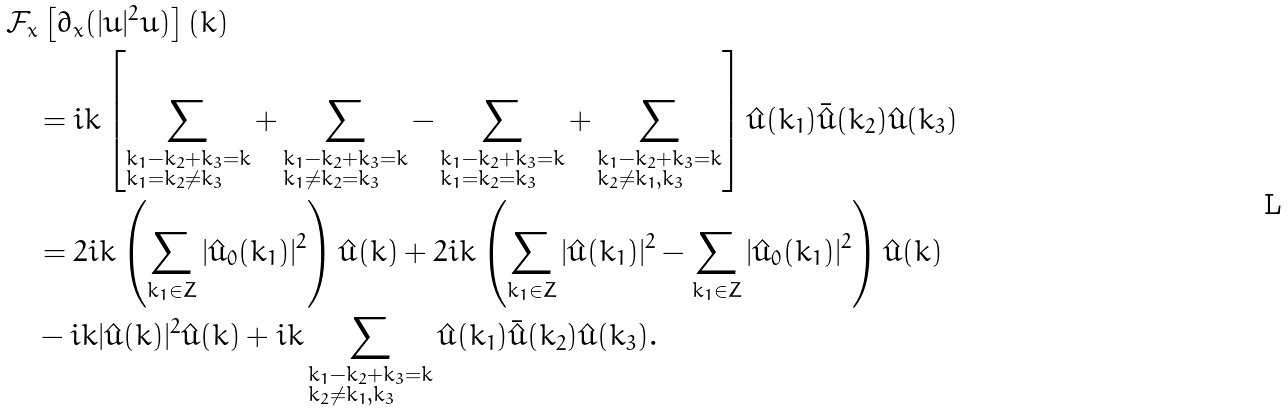Convert formula to latex. <formula><loc_0><loc_0><loc_500><loc_500>& \mathcal { F } _ { x } \left [ \partial _ { x } ( | u | ^ { 2 } u ) \right ] ( k ) \\ & \quad = i k \left [ \sum _ { \begin{subarray} { c } k _ { 1 } - k _ { 2 } + k _ { 3 } = k \\ k _ { 1 } = k _ { 2 } \neq k _ { 3 } \end{subarray} } + \sum _ { \begin{subarray} { c } k _ { 1 } - k _ { 2 } + k _ { 3 } = k \\ k _ { 1 } \neq k _ { 2 } = k _ { 3 } \end{subarray} } - \sum _ { \begin{subarray} { c } k _ { 1 } - k _ { 2 } + k _ { 3 } = k \\ k _ { 1 } = k _ { 2 } = k _ { 3 } \end{subarray} } + \sum _ { \begin{subarray} { c } k _ { 1 } - k _ { 2 } + k _ { 3 } = k \\ k _ { 2 } \neq k _ { 1 } , k _ { 3 } \end{subarray} } \right ] \hat { u } ( k _ { 1 } ) \bar { \hat { u } } ( k _ { 2 } ) \hat { u } ( k _ { 3 } ) \\ & \quad = 2 i k \left ( \sum _ { k _ { 1 } \in Z } | \hat { u } _ { 0 } ( k _ { 1 } ) | ^ { 2 } \right ) \hat { u } ( k ) + 2 i k \left ( \sum _ { k _ { 1 } \in Z } | \hat { u } ( k _ { 1 } ) | ^ { 2 } - \sum _ { k _ { 1 } \in Z } | \hat { u } _ { 0 } ( k _ { 1 } ) | ^ { 2 } \right ) \hat { u } ( k ) \\ & \quad - i k | \hat { u } ( k ) | ^ { 2 } \hat { u } ( k ) + i k \sum _ { \begin{subarray} { c } k _ { 1 } - k _ { 2 } + k _ { 3 } = k \\ k _ { 2 } \neq k _ { 1 } , k _ { 3 } \end{subarray} } \hat { u } ( k _ { 1 } ) \bar { \hat { u } } ( k _ { 2 } ) \hat { u } ( k _ { 3 } ) .</formula> 